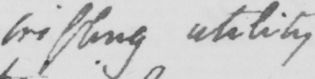Can you read and transcribe this handwriting? trifling utility 